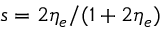<formula> <loc_0><loc_0><loc_500><loc_500>s = 2 \eta _ { e } / ( 1 + 2 \eta _ { e } )</formula> 